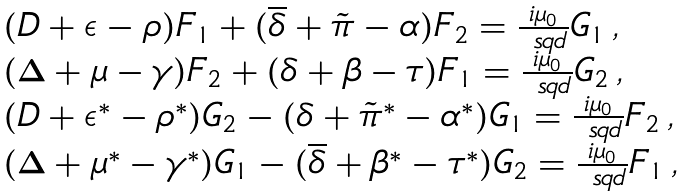Convert formula to latex. <formula><loc_0><loc_0><loc_500><loc_500>\begin{array} { l l } & ( D + \epsilon - \rho ) F _ { 1 } + ( \overline { \delta } + \tilde { \pi } - \alpha ) F _ { 2 } = \frac { i \mu _ { 0 } } { \ s q d } G _ { 1 } \, , \\ & ( \Delta + \mu - \gamma ) F _ { 2 } + ( \delta + \beta - \tau ) F _ { 1 } = \frac { i \mu _ { 0 } } { \ s q d } G _ { 2 } \, , \\ & ( D + \epsilon ^ { * } - \rho ^ { * } ) G _ { 2 } - ( \delta + \tilde { \pi } ^ { * } - \alpha ^ { * } ) G _ { 1 } = \frac { i \mu _ { 0 } } { \ s q d } F _ { 2 } \, , \\ & ( \Delta + \mu ^ { * } - \gamma ^ { * } ) G _ { 1 } - ( \overline { \delta } + \beta ^ { * } - \tau ^ { * } ) G _ { 2 } = \frac { i \mu _ { 0 } } { \ s q d } F _ { 1 } \, , \end{array}</formula> 